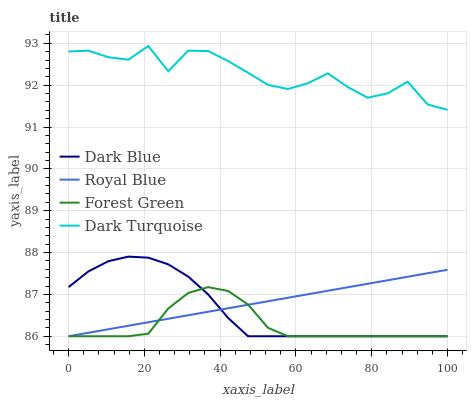Does Forest Green have the minimum area under the curve?
Answer yes or no. Yes. Does Dark Turquoise have the maximum area under the curve?
Answer yes or no. Yes. Does Dark Turquoise have the minimum area under the curve?
Answer yes or no. No. Does Forest Green have the maximum area under the curve?
Answer yes or no. No. Is Royal Blue the smoothest?
Answer yes or no. Yes. Is Dark Turquoise the roughest?
Answer yes or no. Yes. Is Forest Green the smoothest?
Answer yes or no. No. Is Forest Green the roughest?
Answer yes or no. No. Does Dark Blue have the lowest value?
Answer yes or no. Yes. Does Dark Turquoise have the lowest value?
Answer yes or no. No. Does Dark Turquoise have the highest value?
Answer yes or no. Yes. Does Forest Green have the highest value?
Answer yes or no. No. Is Royal Blue less than Dark Turquoise?
Answer yes or no. Yes. Is Dark Turquoise greater than Royal Blue?
Answer yes or no. Yes. Does Dark Blue intersect Royal Blue?
Answer yes or no. Yes. Is Dark Blue less than Royal Blue?
Answer yes or no. No. Is Dark Blue greater than Royal Blue?
Answer yes or no. No. Does Royal Blue intersect Dark Turquoise?
Answer yes or no. No. 